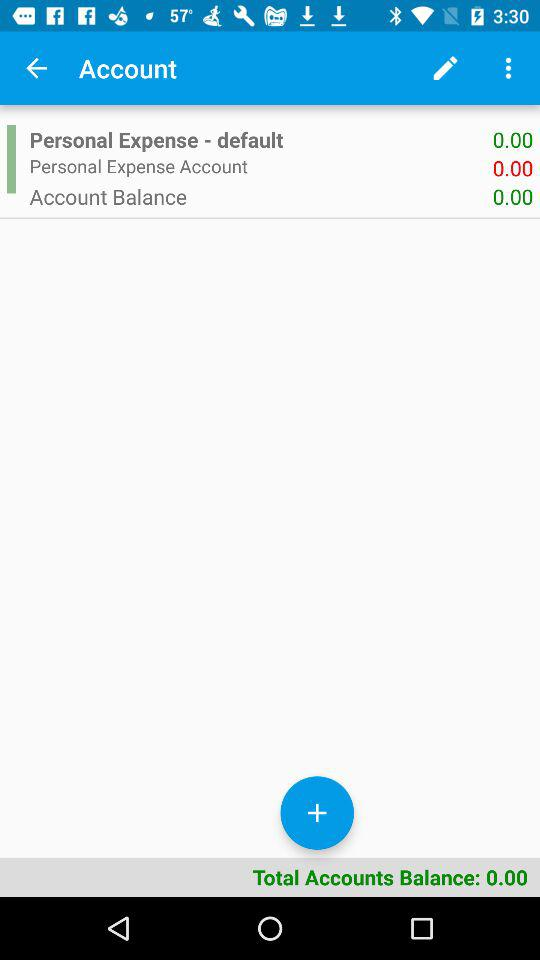What is the default feature considered in the total accounts' balance? The default feature is "Personal Expense". 